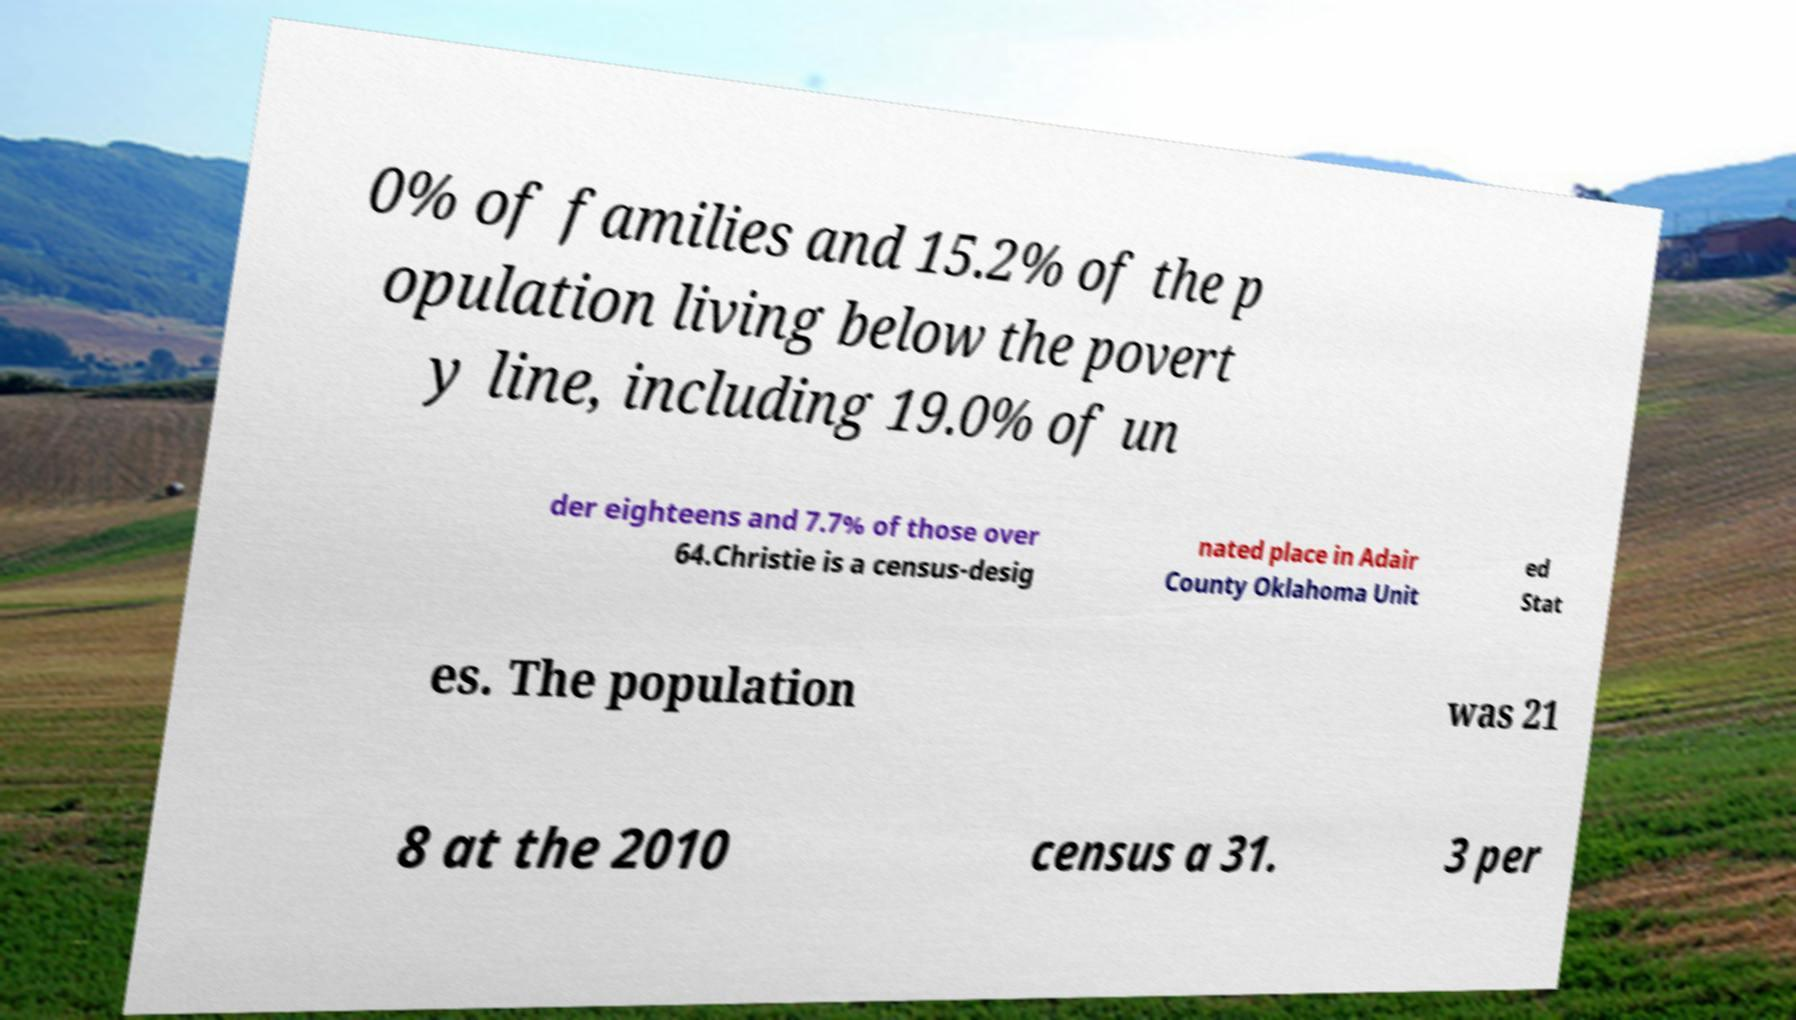I need the written content from this picture converted into text. Can you do that? 0% of families and 15.2% of the p opulation living below the povert y line, including 19.0% of un der eighteens and 7.7% of those over 64.Christie is a census-desig nated place in Adair County Oklahoma Unit ed Stat es. The population was 21 8 at the 2010 census a 31. 3 per 